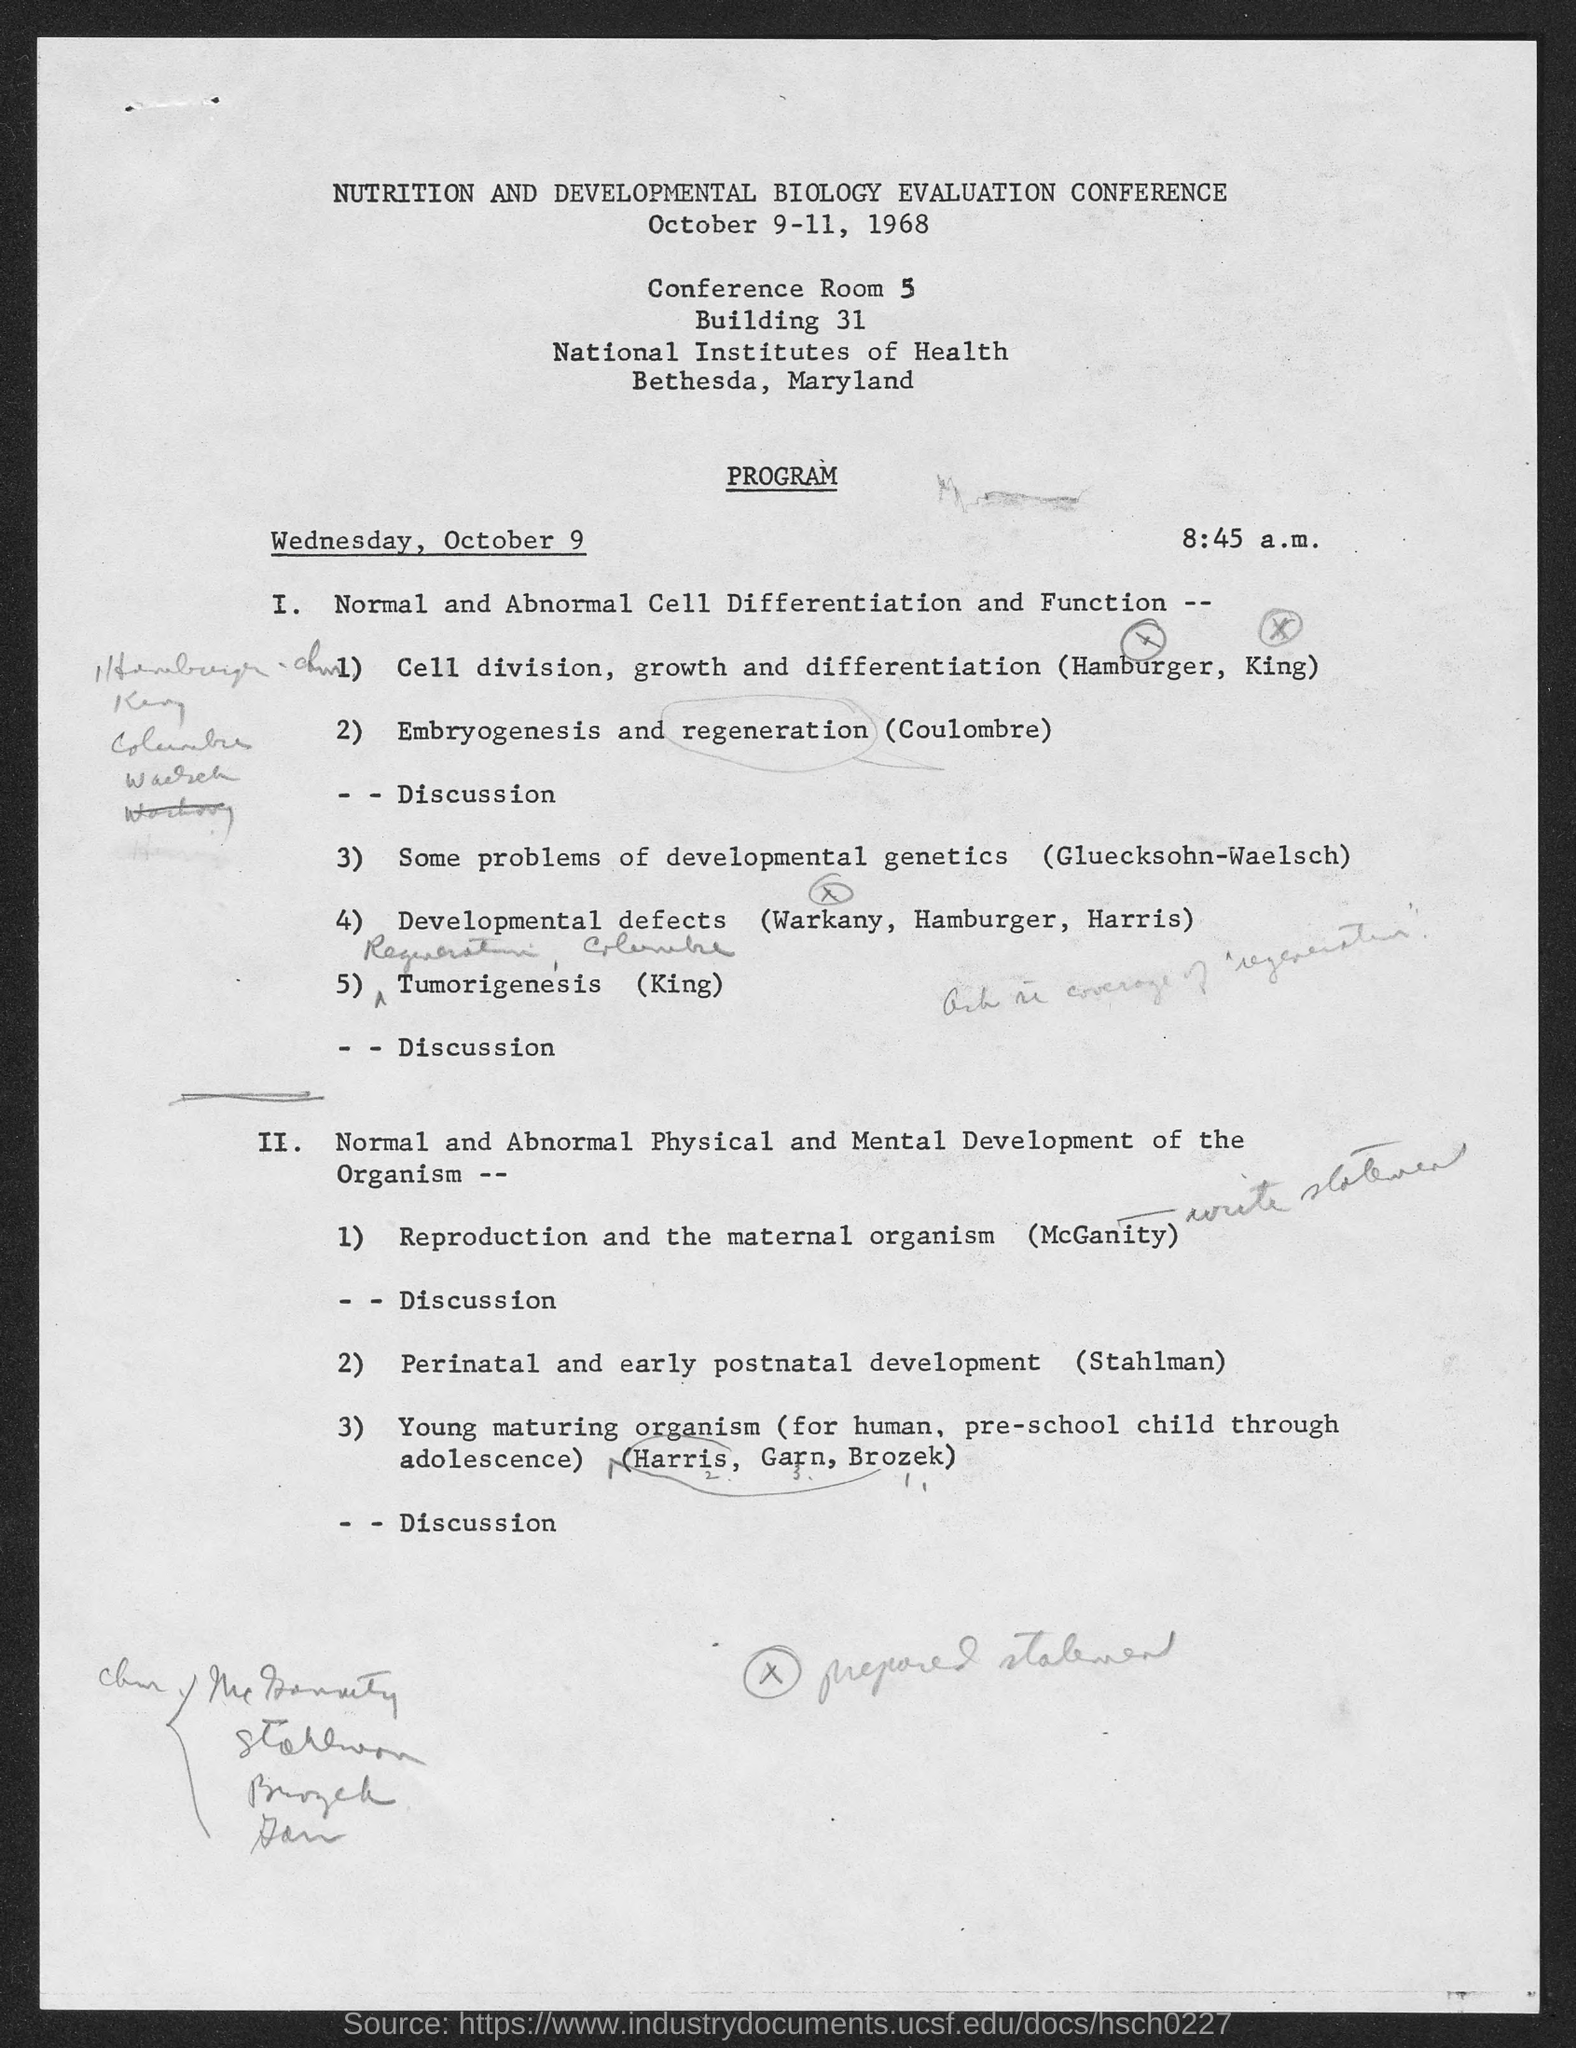When is the Conference?
Offer a terse response. October 9-11, 1968. Who presents Tumorigenesis?
Give a very brief answer. King. 